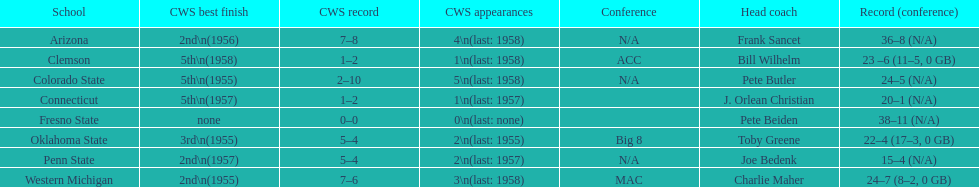List each of the schools that came in 2nd for cws best finish. Arizona, Penn State, Western Michigan. 